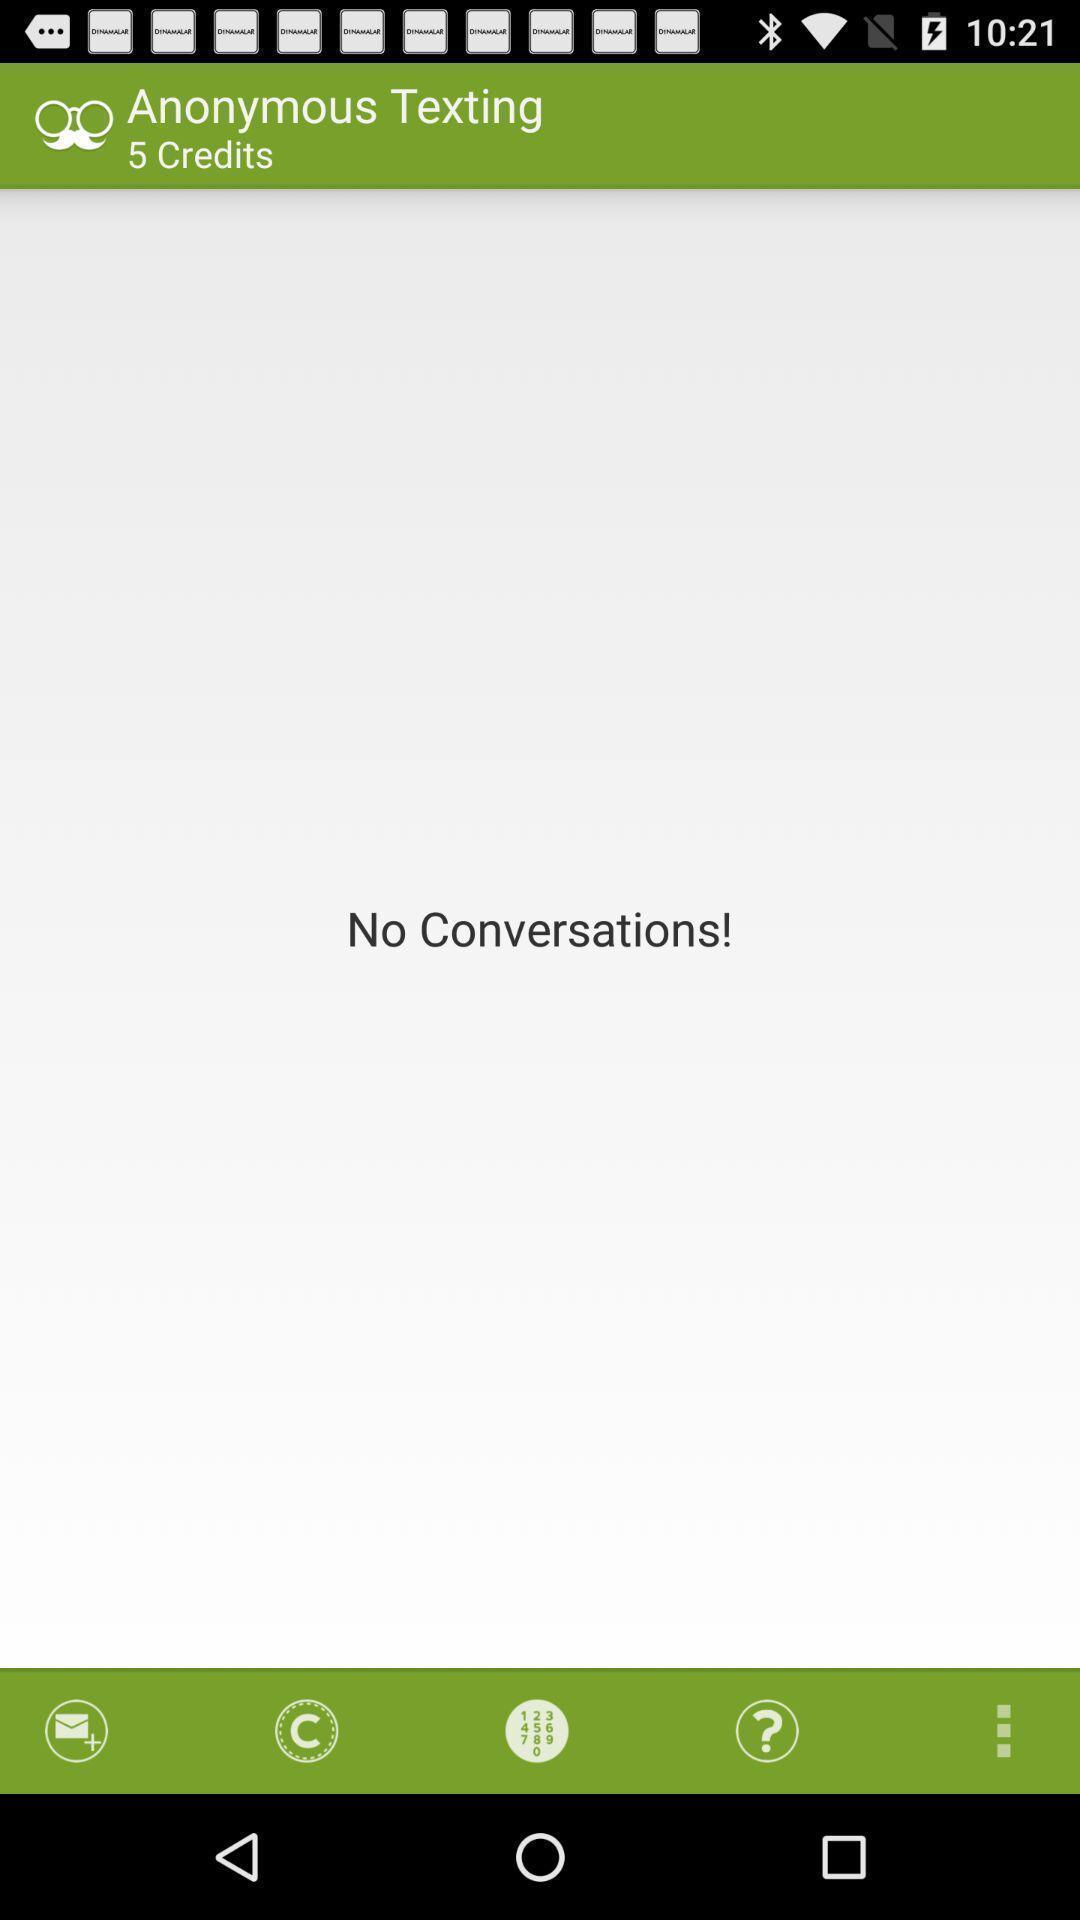Describe the visual elements of this screenshot. Page of a chatting application. 